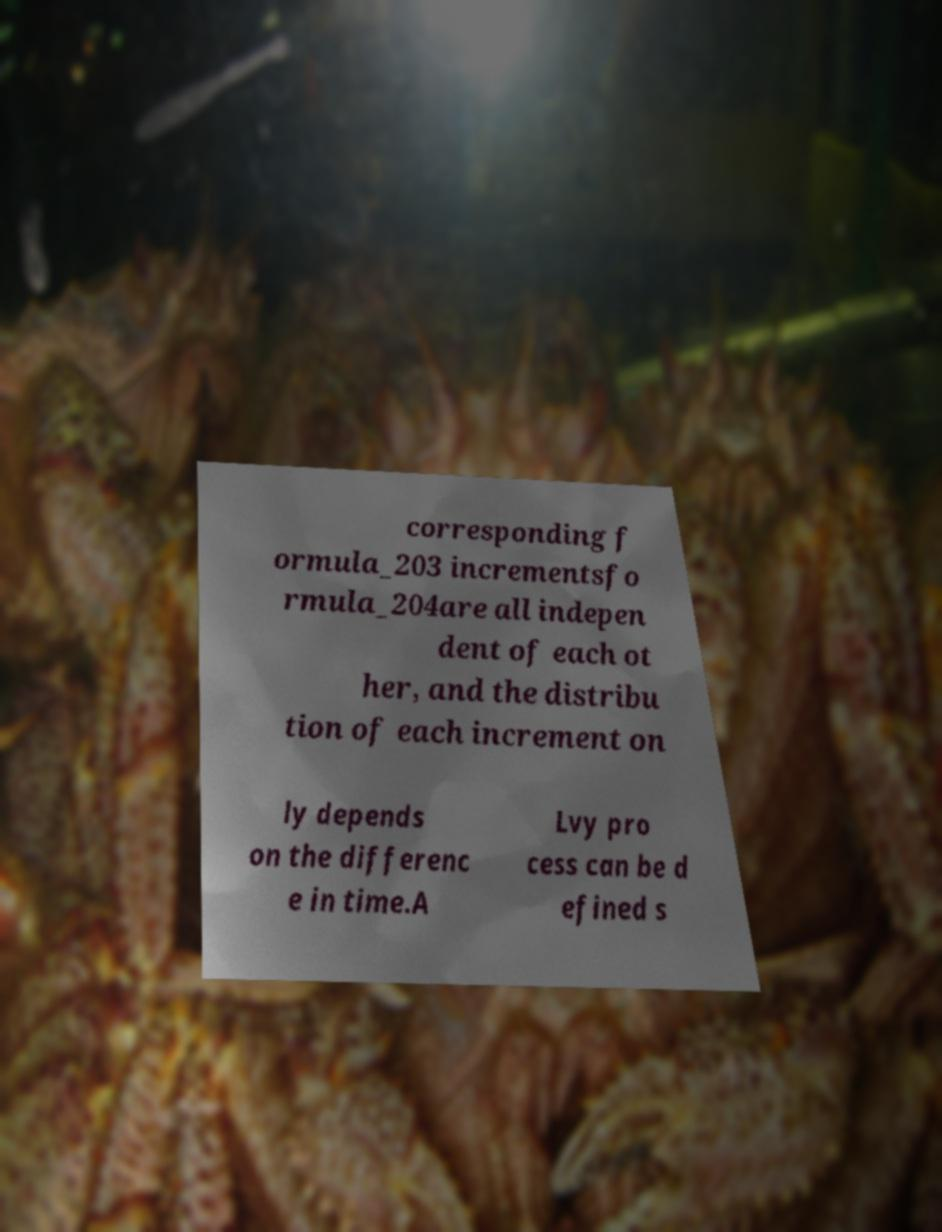Can you read and provide the text displayed in the image?This photo seems to have some interesting text. Can you extract and type it out for me? corresponding f ormula_203 incrementsfo rmula_204are all indepen dent of each ot her, and the distribu tion of each increment on ly depends on the differenc e in time.A Lvy pro cess can be d efined s 